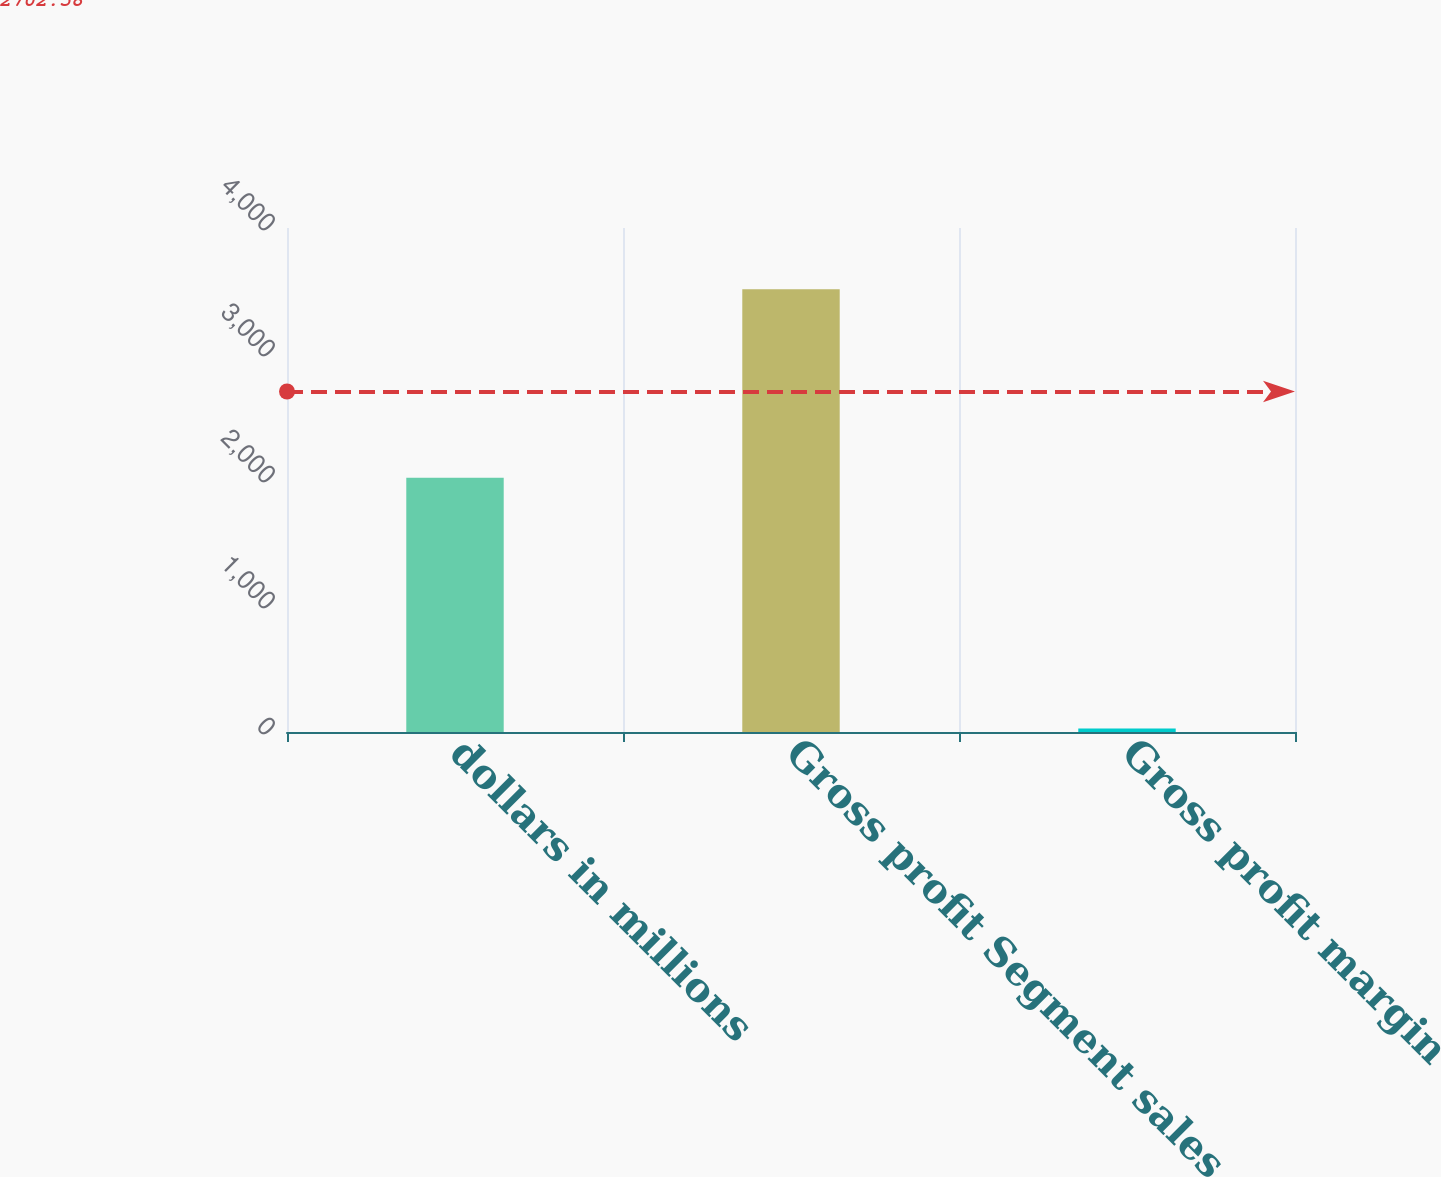<chart> <loc_0><loc_0><loc_500><loc_500><bar_chart><fcel>dollars in millions<fcel>Gross profit Segment sales<fcel>Gross profit margin<nl><fcel>2018<fcel>3513.6<fcel>28.2<nl></chart> 